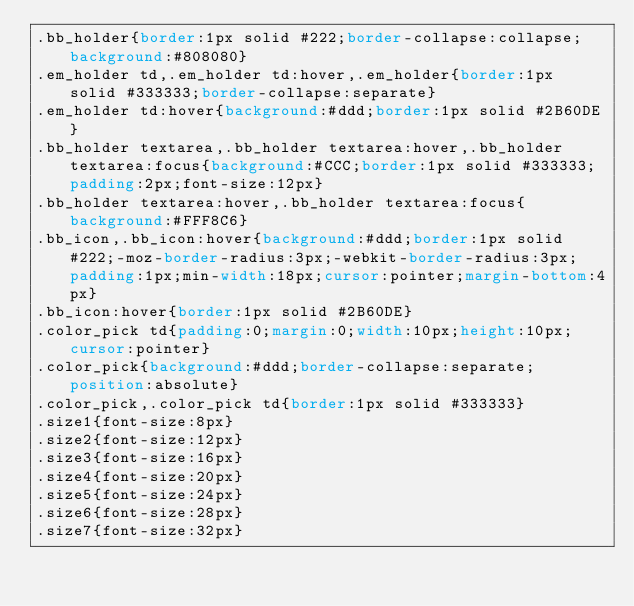<code> <loc_0><loc_0><loc_500><loc_500><_CSS_>.bb_holder{border:1px solid #222;border-collapse:collapse;background:#808080}
.em_holder td,.em_holder td:hover,.em_holder{border:1px solid #333333;border-collapse:separate}
.em_holder td:hover{background:#ddd;border:1px solid #2B60DE}
.bb_holder textarea,.bb_holder textarea:hover,.bb_holder textarea:focus{background:#CCC;border:1px solid #333333;padding:2px;font-size:12px}
.bb_holder textarea:hover,.bb_holder textarea:focus{background:#FFF8C6}
.bb_icon,.bb_icon:hover{background:#ddd;border:1px solid #222;-moz-border-radius:3px;-webkit-border-radius:3px;padding:1px;min-width:18px;cursor:pointer;margin-bottom:4px}
.bb_icon:hover{border:1px solid #2B60DE}
.color_pick td{padding:0;margin:0;width:10px;height:10px;cursor:pointer}
.color_pick{background:#ddd;border-collapse:separate;position:absolute}
.color_pick,.color_pick td{border:1px solid #333333}
.size1{font-size:8px}
.size2{font-size:12px}
.size3{font-size:16px}
.size4{font-size:20px}
.size5{font-size:24px}
.size6{font-size:28px}
.size7{font-size:32px}</code> 